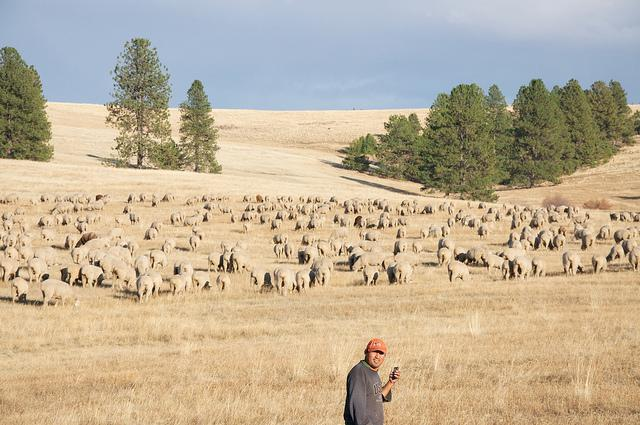Why is he standing far from the animals? safety 